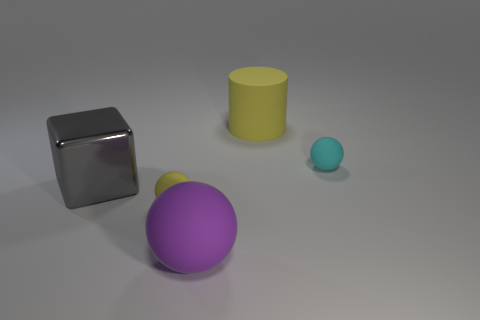How would the scene change if the cube were made of glass instead of metal? If the cube were made of glass, the scene would change significantly. The transparency and refractive qualities of glass would allow us to see through the cube, the objects behind it would be visible but distorted, and the light would bend and create intricate patterns of light and shadow in the scene, adding a new layer of complexity to the image's composition. 